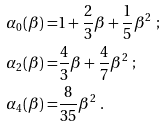Convert formula to latex. <formula><loc_0><loc_0><loc_500><loc_500>\alpha _ { 0 } ( \beta ) = & 1 + \frac { 2 } { 3 } \beta + \frac { 1 } { 5 } \beta ^ { 2 } \ ; \\ \alpha _ { 2 } ( \beta ) = & \frac { 4 } { 3 } \beta + \frac { 4 } { 7 } \beta ^ { 2 } \ ; \\ \alpha _ { 4 } ( \beta ) = & \frac { 8 } { 3 5 } \beta ^ { 2 } \ .</formula> 